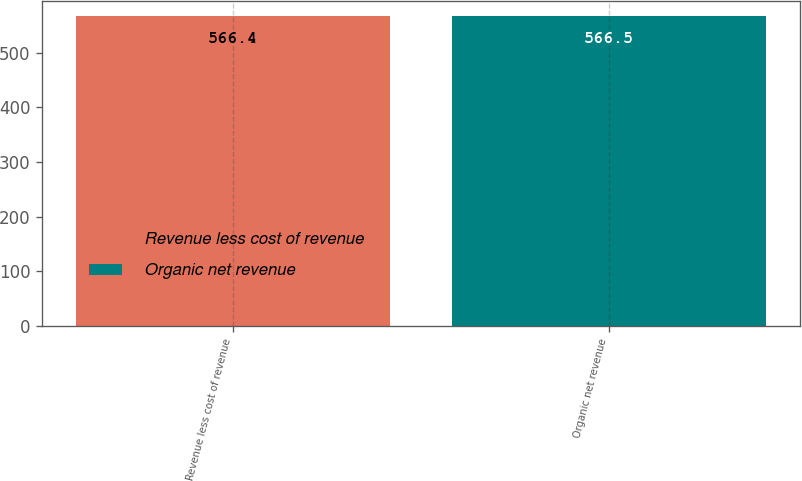Convert chart to OTSL. <chart><loc_0><loc_0><loc_500><loc_500><bar_chart><fcel>Revenue less cost of revenue<fcel>Organic net revenue<nl><fcel>566.4<fcel>566.5<nl></chart> 